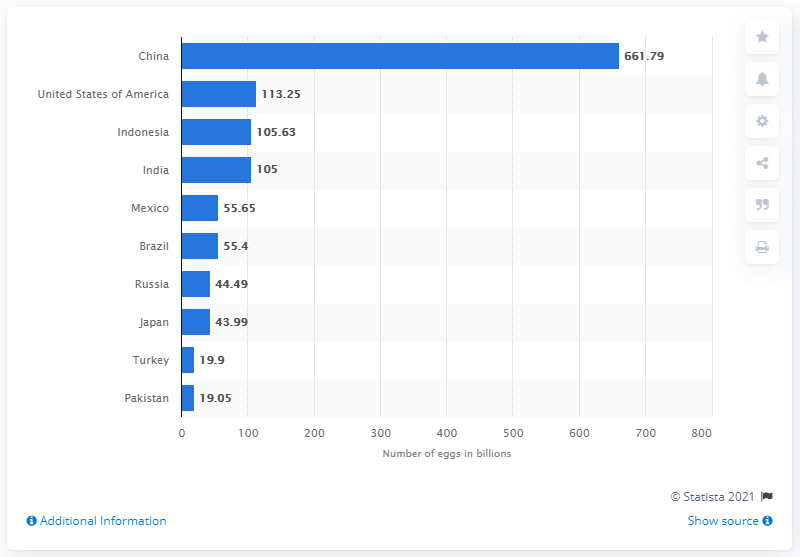Point out several critical features in this image. In 2019, a total of 661.79 million eggs were produced in China. In 2019, Turkey and Pakistan had a total of approximately 38.95 billion eggs. In 2019, China was the leading country in terms of egg production, with an estimated total of billions of eggs. 